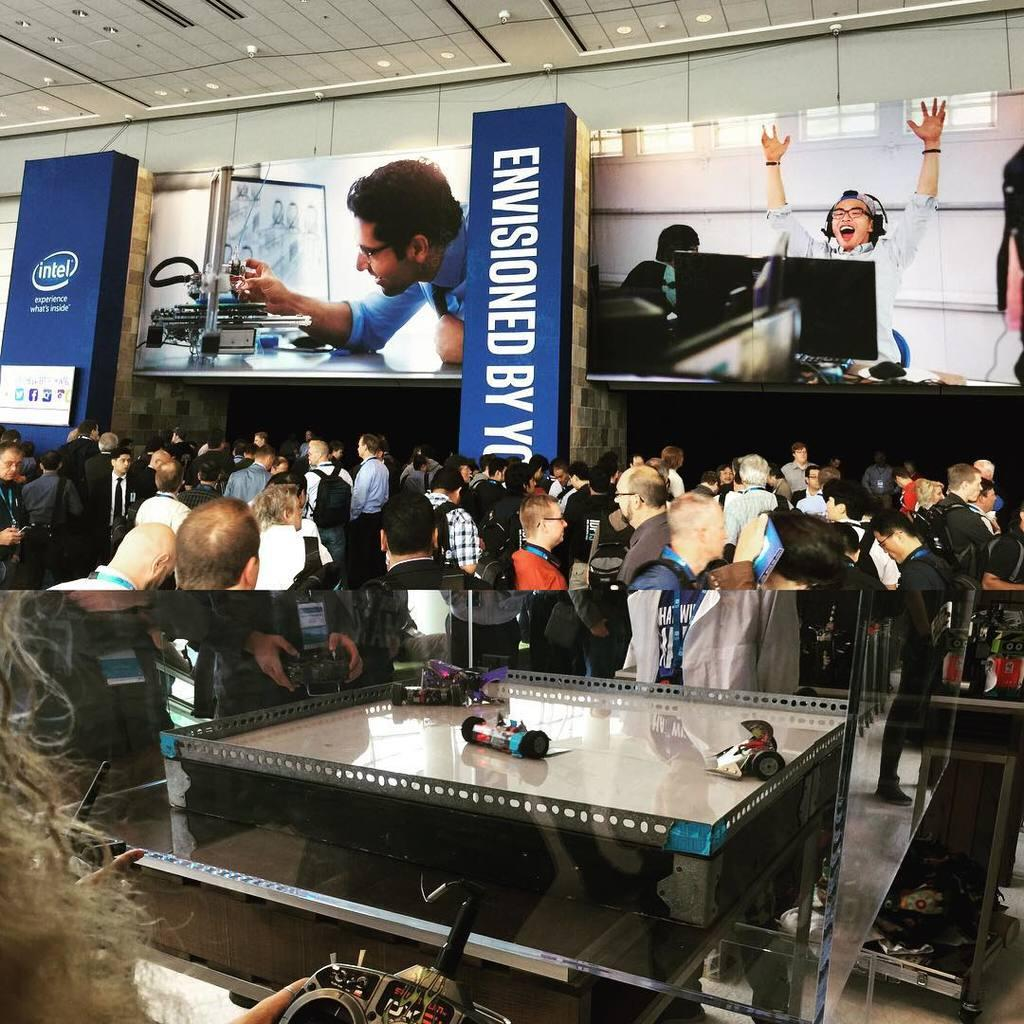What type of image is being described? The image is animated. What can be seen in the image? There are people standing in the image. What language is being spoken by the people in the image? There is no information provided about the language being spoken by the people in the image. 